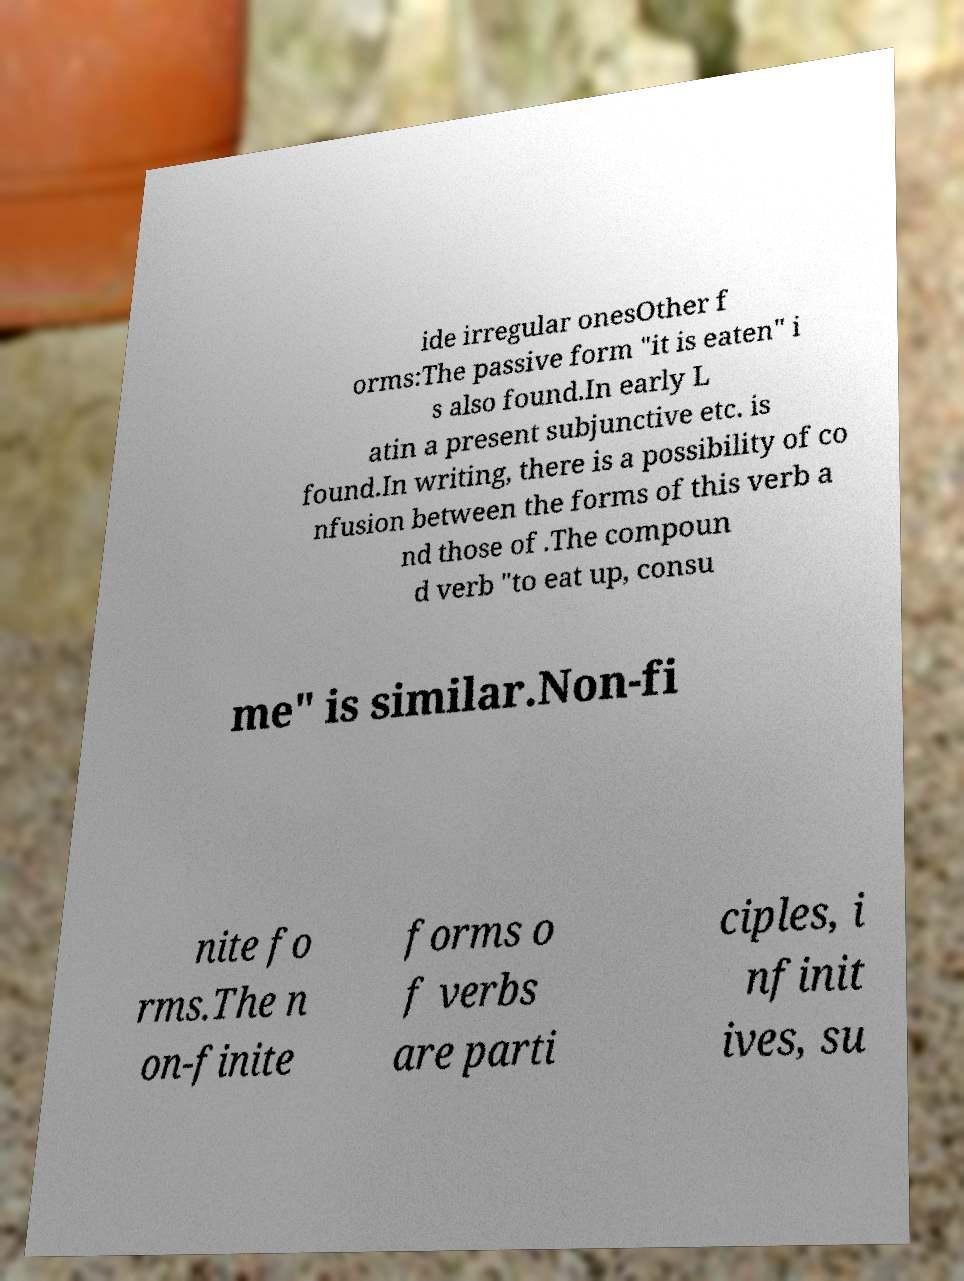Could you extract and type out the text from this image? ide irregular onesOther f orms:The passive form "it is eaten" i s also found.In early L atin a present subjunctive etc. is found.In writing, there is a possibility of co nfusion between the forms of this verb a nd those of .The compoun d verb "to eat up, consu me" is similar.Non-fi nite fo rms.The n on-finite forms o f verbs are parti ciples, i nfinit ives, su 